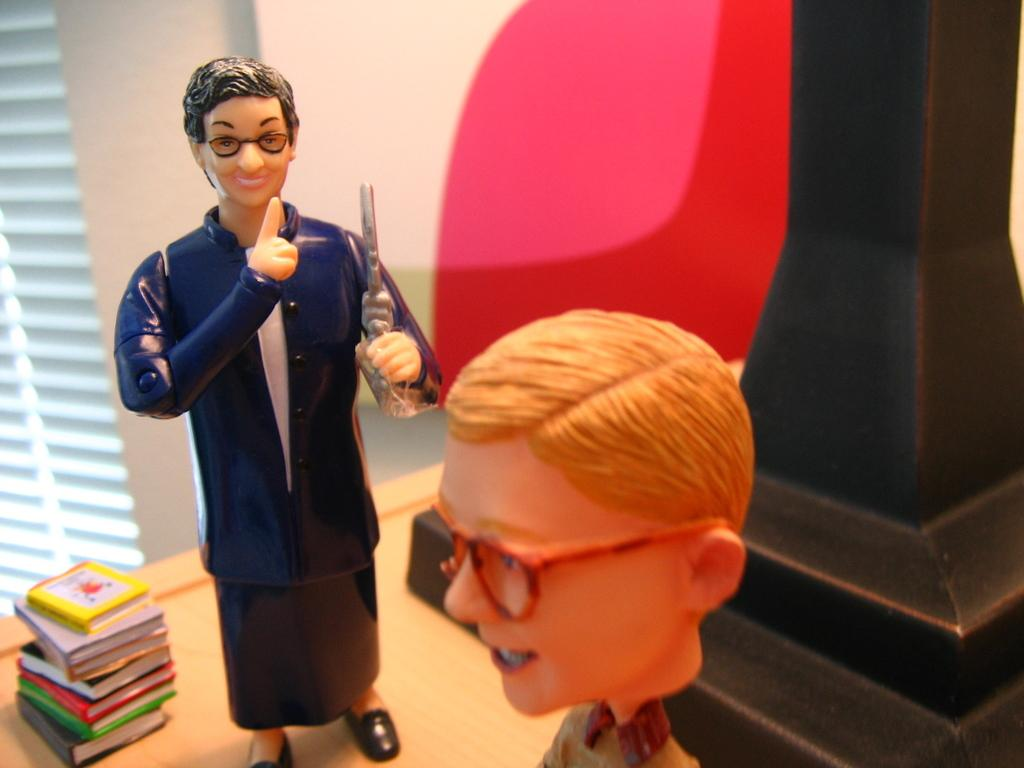What objects are placed on the table in the image? There are toys placed on the table in the image. What can be seen on the left side of the image? There are books and a window on the left side of the image. What is visible in the background of the image? There is a wall in the background of the image. What type of canvas is being used to paint a picture in the image? There is no canvas or painting present in the image. What is the temper of the person in the image? There is no person present in the image, so it is not possible to determine their temper. 